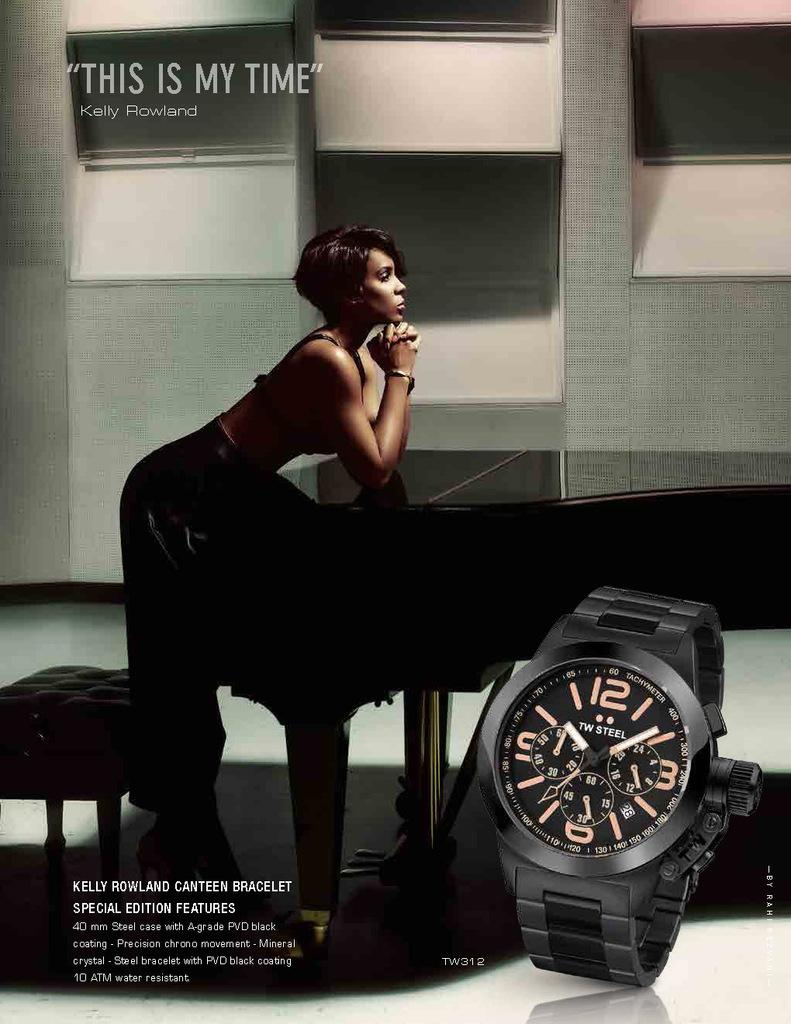<image>
Render a clear and concise summary of the photo. Kelly Rowland leans on a piano in a sultry advert which features a watch in the forefront 